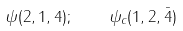Convert formula to latex. <formula><loc_0><loc_0><loc_500><loc_500>\psi ( 2 , 1 , 4 ) ; \quad \psi _ { c } ( 1 , 2 , \bar { 4 } )</formula> 